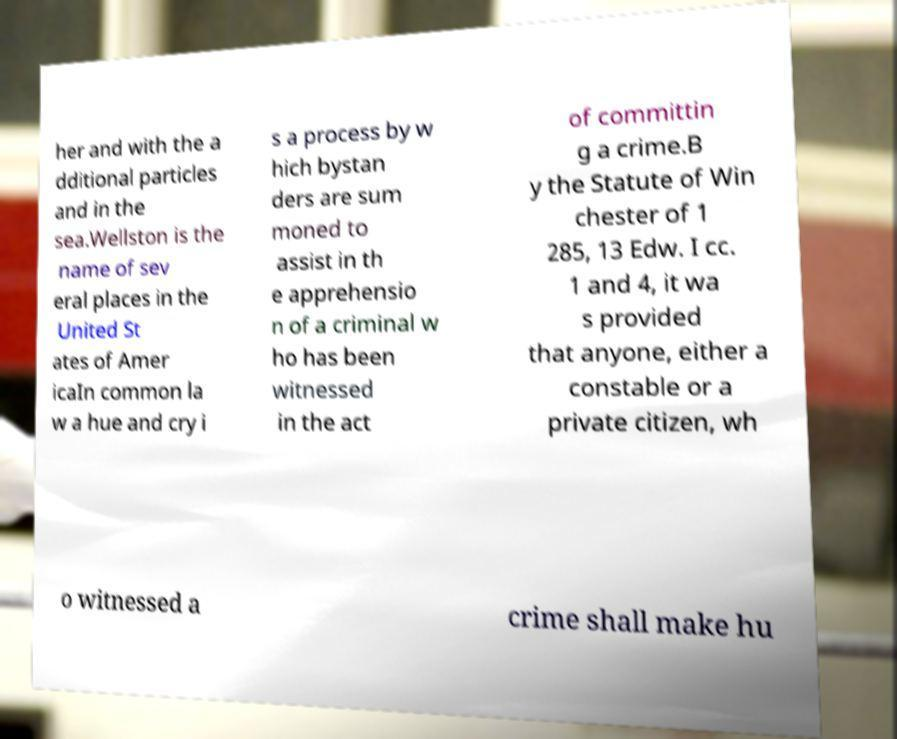Could you extract and type out the text from this image? her and with the a dditional particles and in the sea.Wellston is the name of sev eral places in the United St ates of Amer icaIn common la w a hue and cry i s a process by w hich bystan ders are sum moned to assist in th e apprehensio n of a criminal w ho has been witnessed in the act of committin g a crime.B y the Statute of Win chester of 1 285, 13 Edw. I cc. 1 and 4, it wa s provided that anyone, either a constable or a private citizen, wh o witnessed a crime shall make hu 